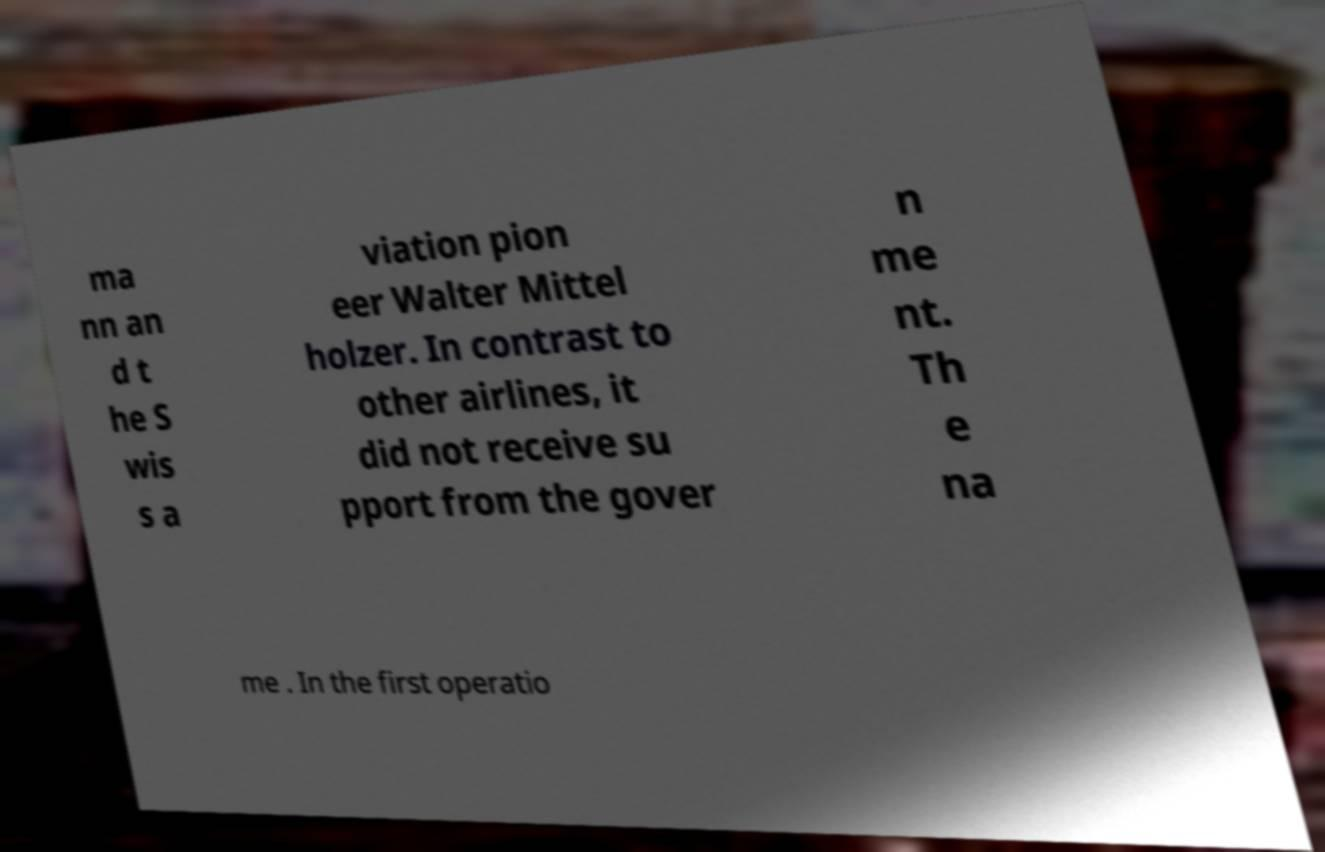There's text embedded in this image that I need extracted. Can you transcribe it verbatim? ma nn an d t he S wis s a viation pion eer Walter Mittel holzer. In contrast to other airlines, it did not receive su pport from the gover n me nt. Th e na me . In the first operatio 